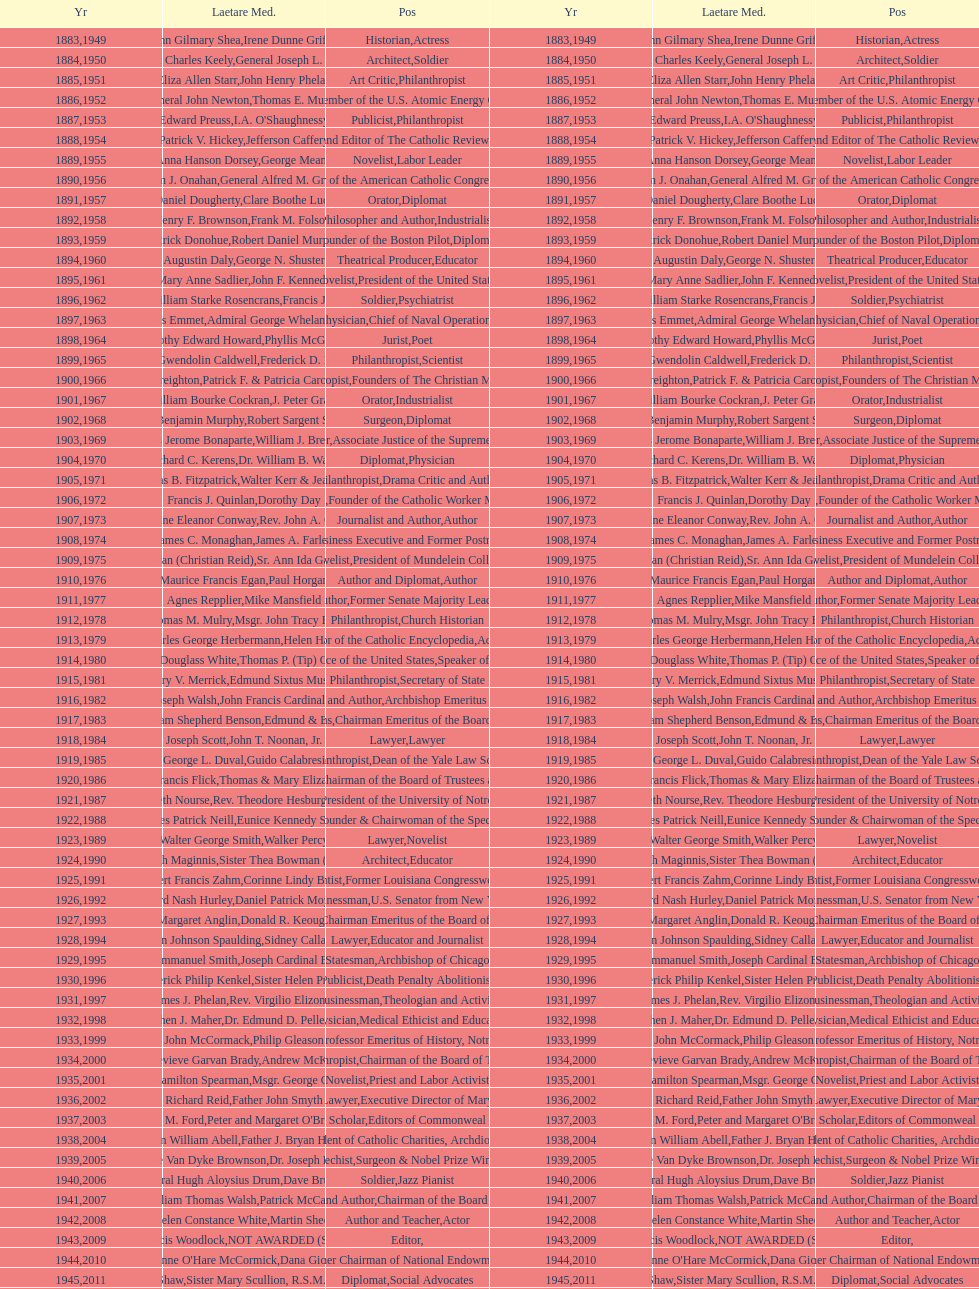How many times does philanthropist appear in the position column on this chart? 9. 